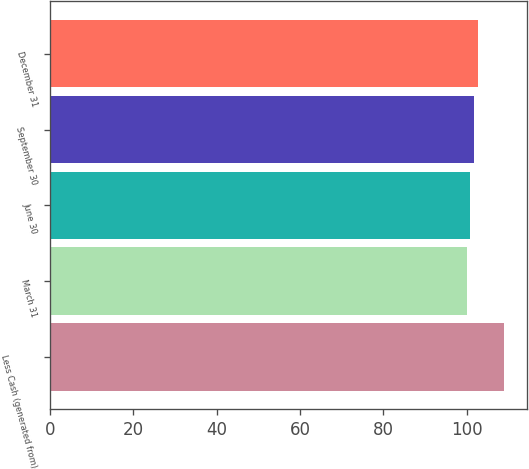Convert chart to OTSL. <chart><loc_0><loc_0><loc_500><loc_500><bar_chart><fcel>Less Cash (generated from)<fcel>March 31<fcel>June 30<fcel>September 30<fcel>December 31<nl><fcel>109<fcel>100<fcel>100.9<fcel>101.8<fcel>102.7<nl></chart> 